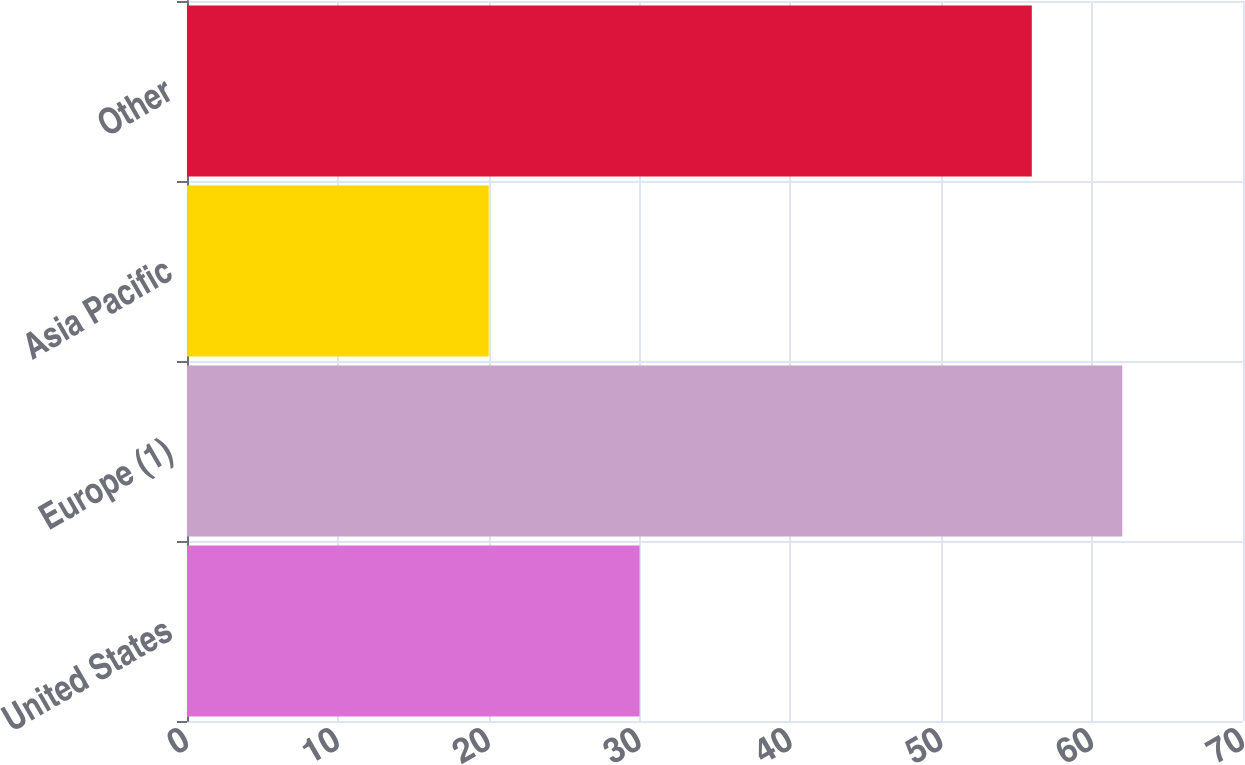Convert chart. <chart><loc_0><loc_0><loc_500><loc_500><bar_chart><fcel>United States<fcel>Europe (1)<fcel>Asia Pacific<fcel>Other<nl><fcel>30<fcel>62<fcel>20<fcel>56<nl></chart> 